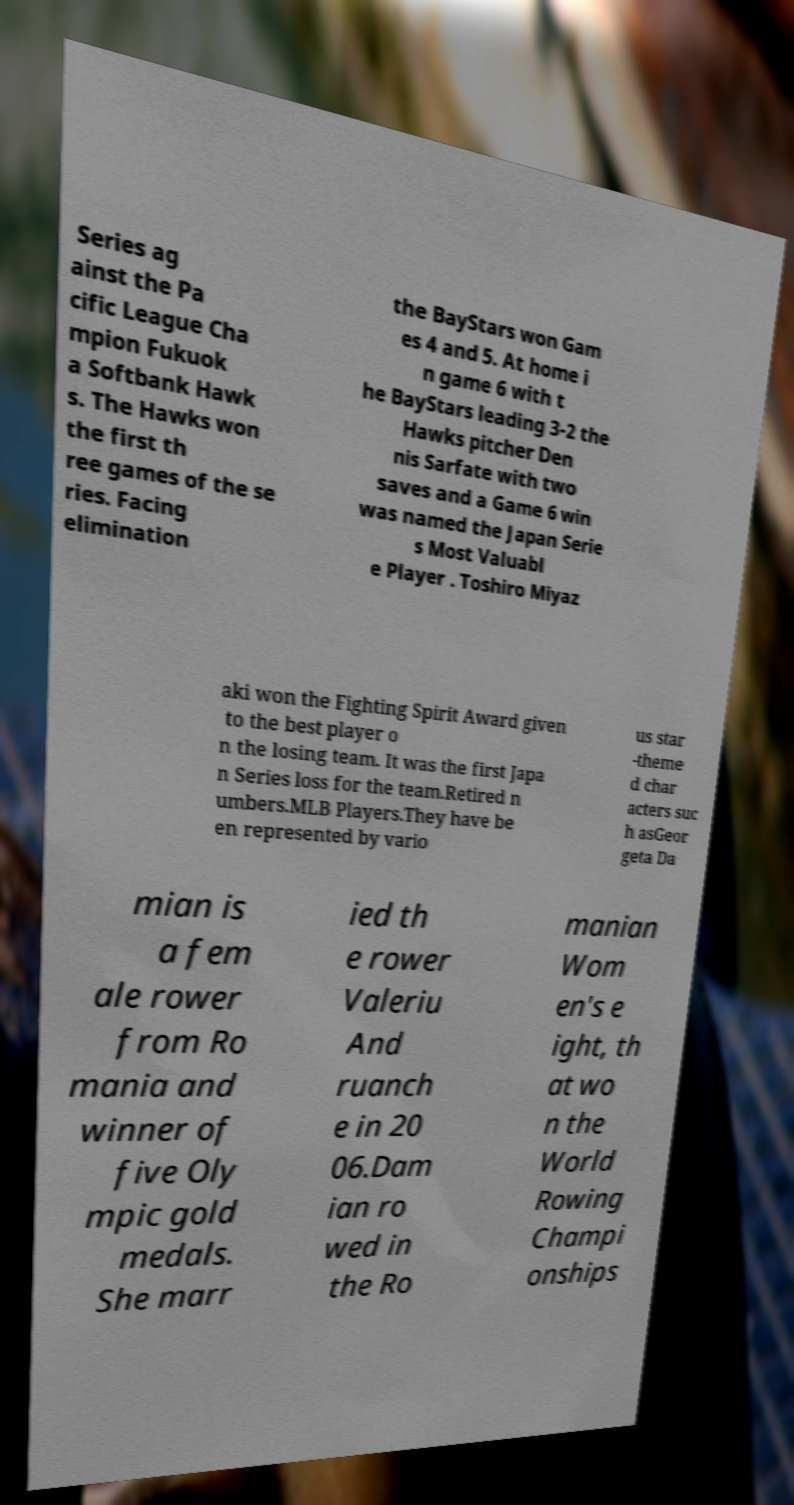Could you extract and type out the text from this image? Series ag ainst the Pa cific League Cha mpion Fukuok a Softbank Hawk s. The Hawks won the first th ree games of the se ries. Facing elimination the BayStars won Gam es 4 and 5. At home i n game 6 with t he BayStars leading 3-2 the Hawks pitcher Den nis Sarfate with two saves and a Game 6 win was named the Japan Serie s Most Valuabl e Player . Toshiro Miyaz aki won the Fighting Spirit Award given to the best player o n the losing team. It was the first Japa n Series loss for the team.Retired n umbers.MLB Players.They have be en represented by vario us star -theme d char acters suc h asGeor geta Da mian is a fem ale rower from Ro mania and winner of five Oly mpic gold medals. She marr ied th e rower Valeriu And ruanch e in 20 06.Dam ian ro wed in the Ro manian Wom en's e ight, th at wo n the World Rowing Champi onships 